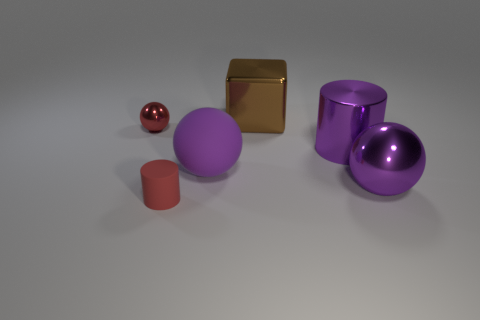What is the texture and color of the small ball? The small ball has a reflective, shiny surface and is red in color, exhibiting a glossy finish which contrasts with the other objects in the image. 